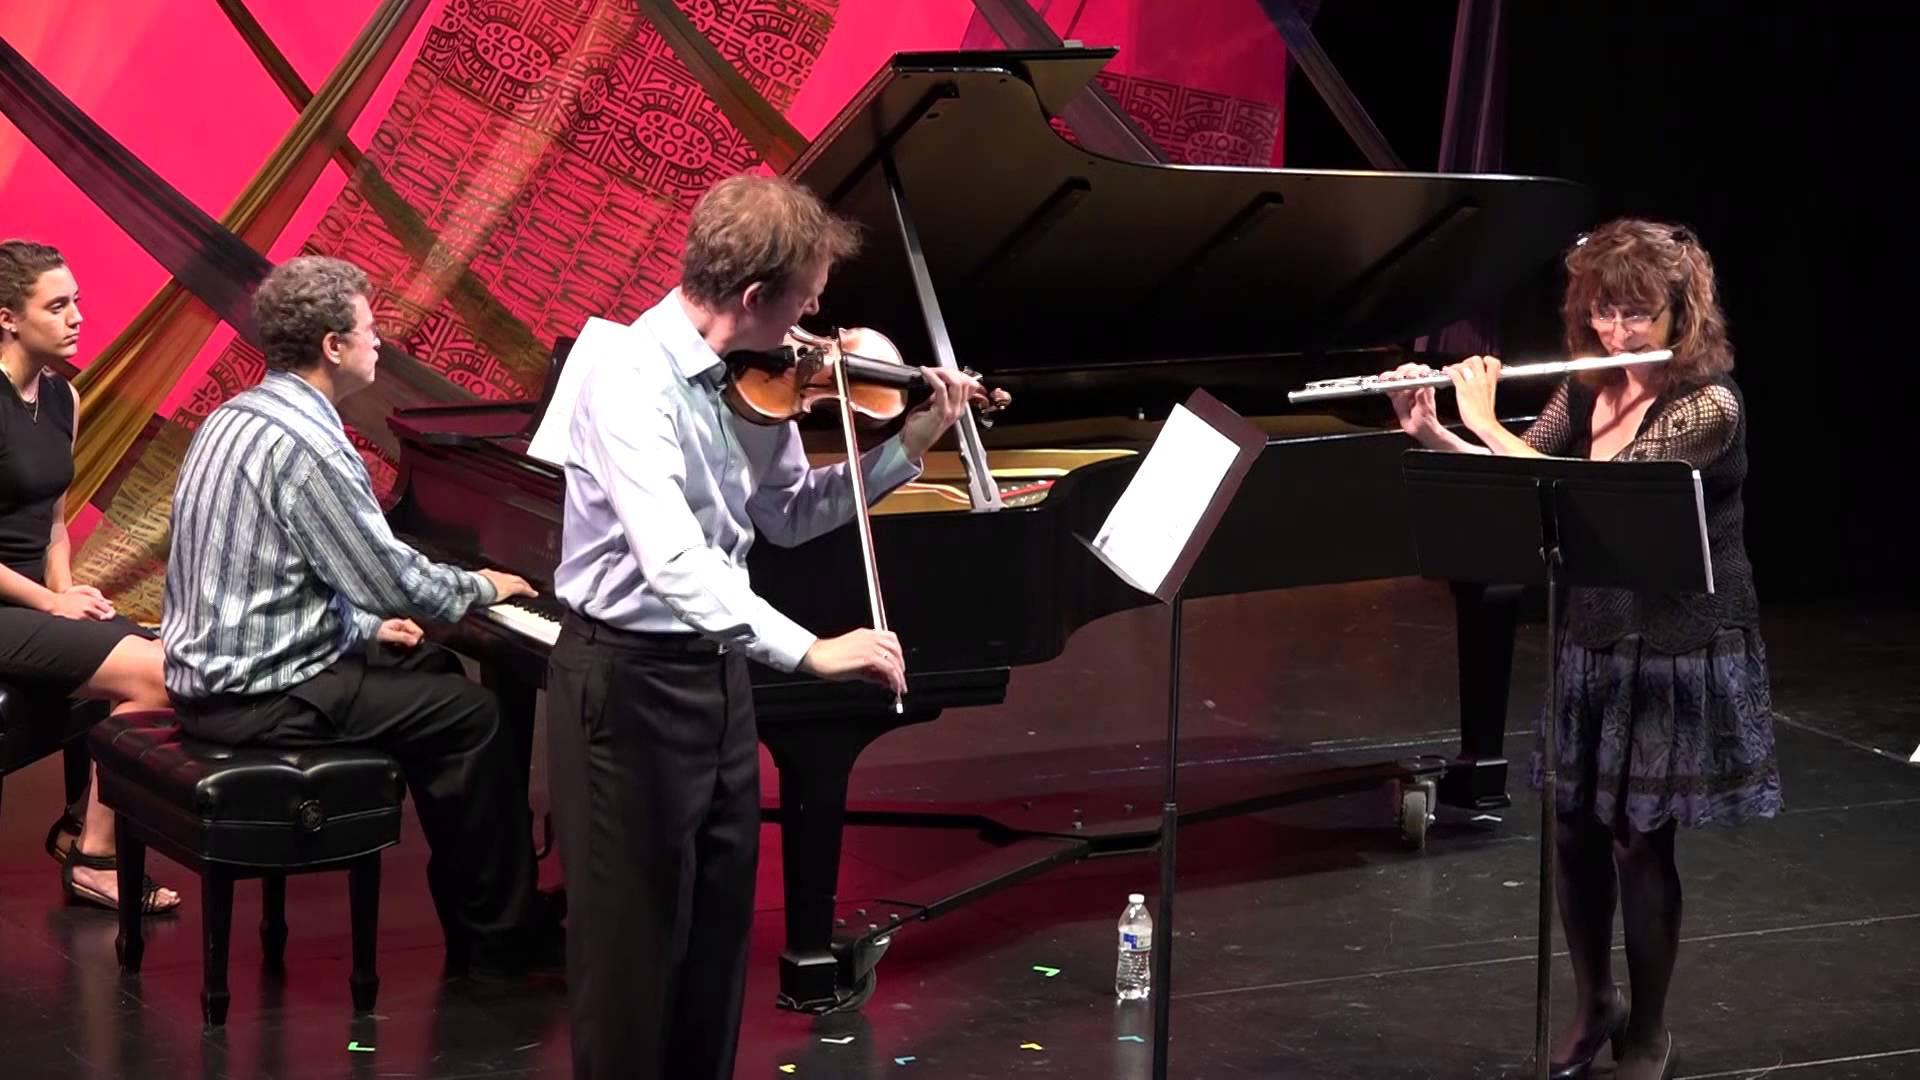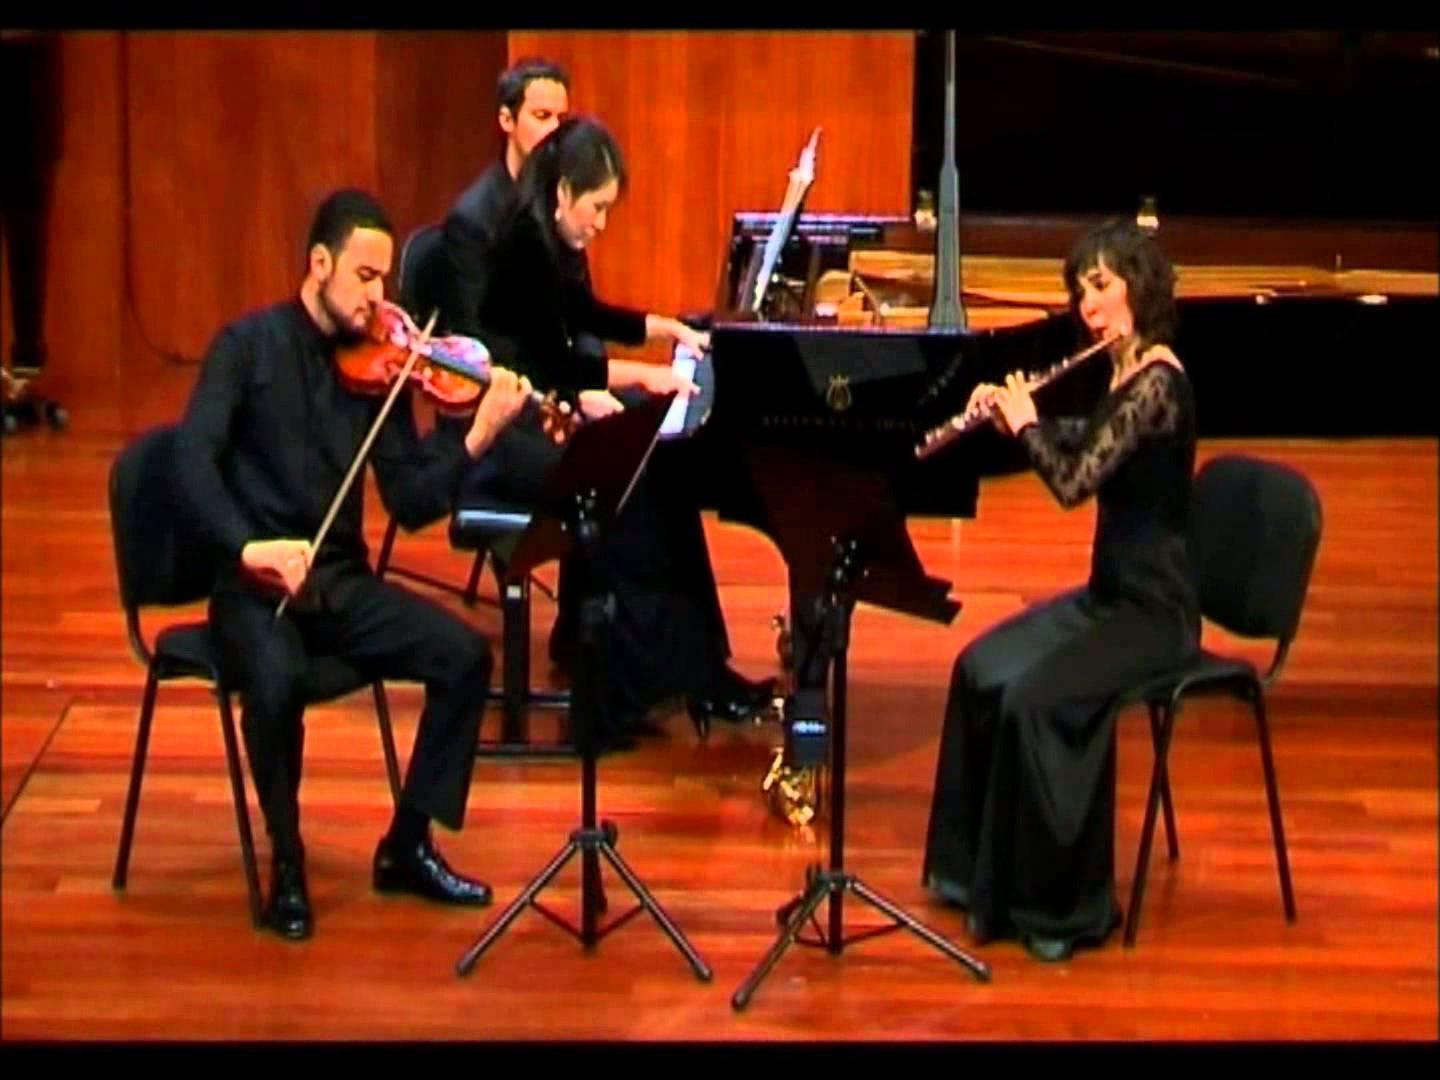The first image is the image on the left, the second image is the image on the right. Analyze the images presented: Is the assertion "Two girls are positioned to the right of a violinist while holding a flute to their mouth." valid? Answer yes or no. Yes. The first image is the image on the left, the second image is the image on the right. Examine the images to the left and right. Is the description "There are exactly six musicians playing instruments, three in each image." accurate? Answer yes or no. No. 